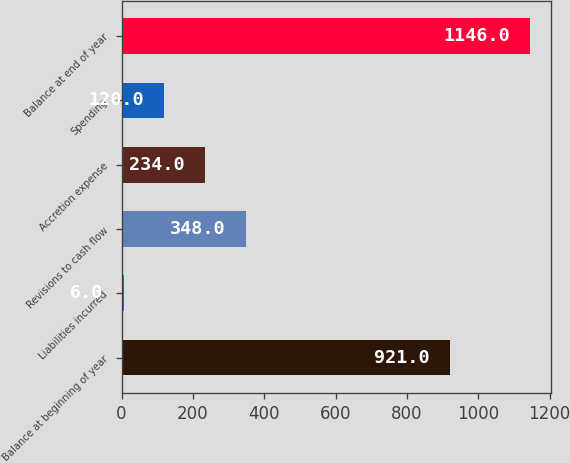<chart> <loc_0><loc_0><loc_500><loc_500><bar_chart><fcel>Balance at beginning of year<fcel>Liabilities incurred<fcel>Revisions to cash flow<fcel>Accretion expense<fcel>Spending<fcel>Balance at end of year<nl><fcel>921<fcel>6<fcel>348<fcel>234<fcel>120<fcel>1146<nl></chart> 